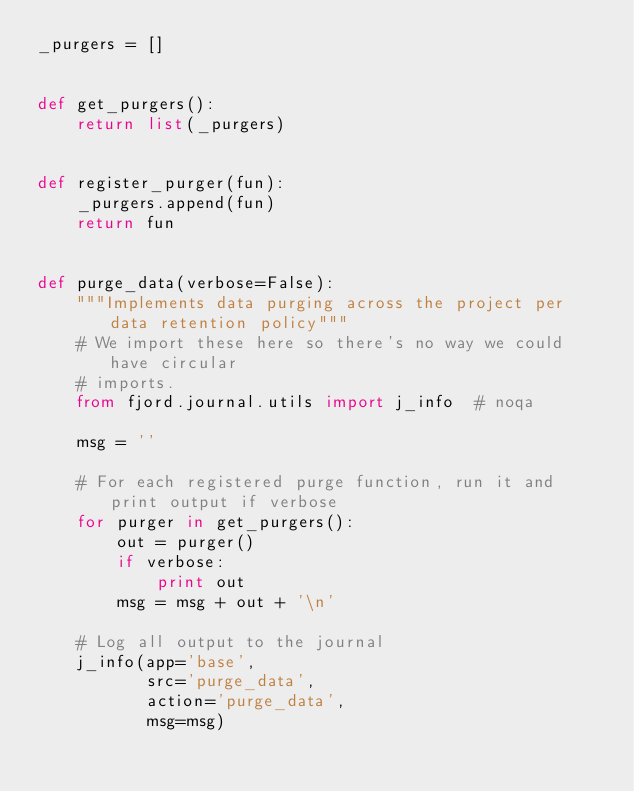<code> <loc_0><loc_0><loc_500><loc_500><_Python_>_purgers = []


def get_purgers():
    return list(_purgers)


def register_purger(fun):
    _purgers.append(fun)
    return fun


def purge_data(verbose=False):
    """Implements data purging across the project per data retention policy"""
    # We import these here so there's no way we could have circular
    # imports.
    from fjord.journal.utils import j_info  # noqa

    msg = ''

    # For each registered purge function, run it and print output if verbose
    for purger in get_purgers():
        out = purger()
        if verbose:
            print out
        msg = msg + out + '\n'

    # Log all output to the journal
    j_info(app='base',
           src='purge_data',
           action='purge_data',
           msg=msg)
</code> 